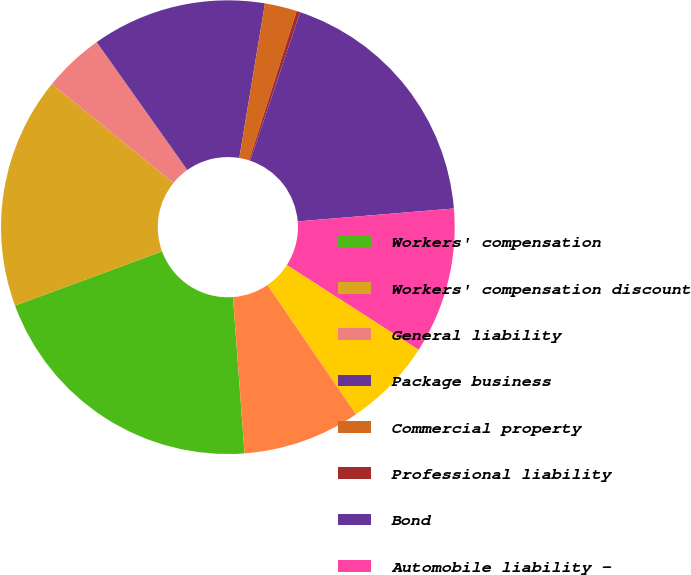Convert chart to OTSL. <chart><loc_0><loc_0><loc_500><loc_500><pie_chart><fcel>Workers' compensation<fcel>Workers' compensation discount<fcel>General liability<fcel>Package business<fcel>Commercial property<fcel>Professional liability<fcel>Bond<fcel>Automobile liability -<fcel>Homeowners<fcel>Catastrophes<nl><fcel>20.55%<fcel>16.49%<fcel>4.32%<fcel>12.43%<fcel>2.29%<fcel>0.26%<fcel>18.52%<fcel>10.41%<fcel>6.35%<fcel>8.38%<nl></chart> 